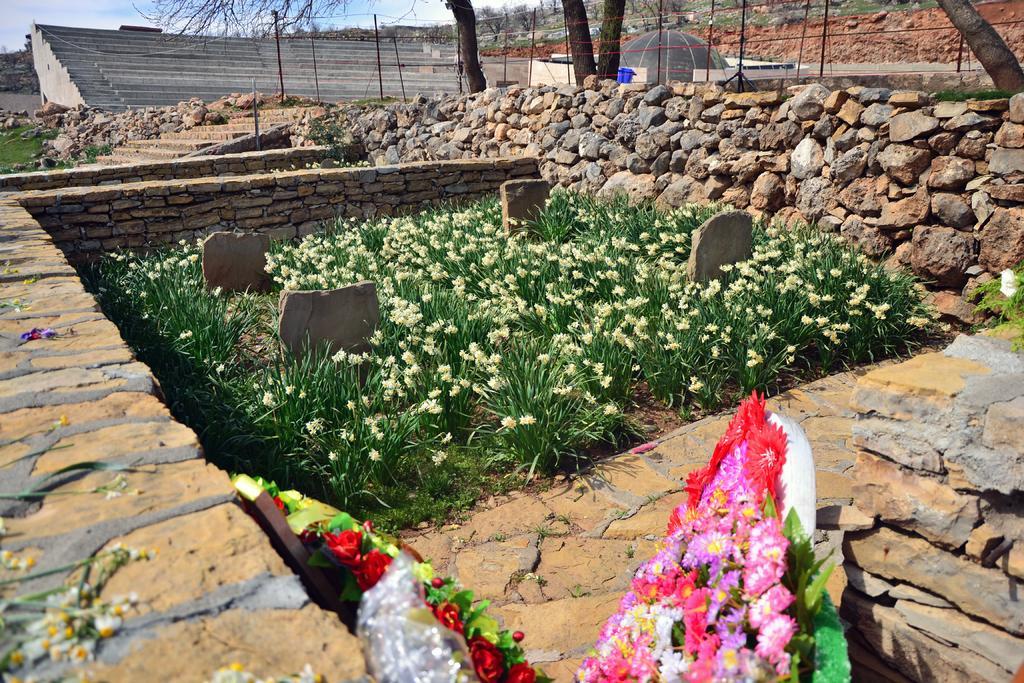How would you summarize this image in a sentence or two? In the left and bottom we can see a stone wall fence on both side of the image, in between flowering plants are there and at the bottom flower bouquet is there. On the top left sky is visible blue in color and tree trunk are visible. In the middle right but is there. In the left grass is visible. In the top mountains are visible. This image is taken during day time in the ground. 